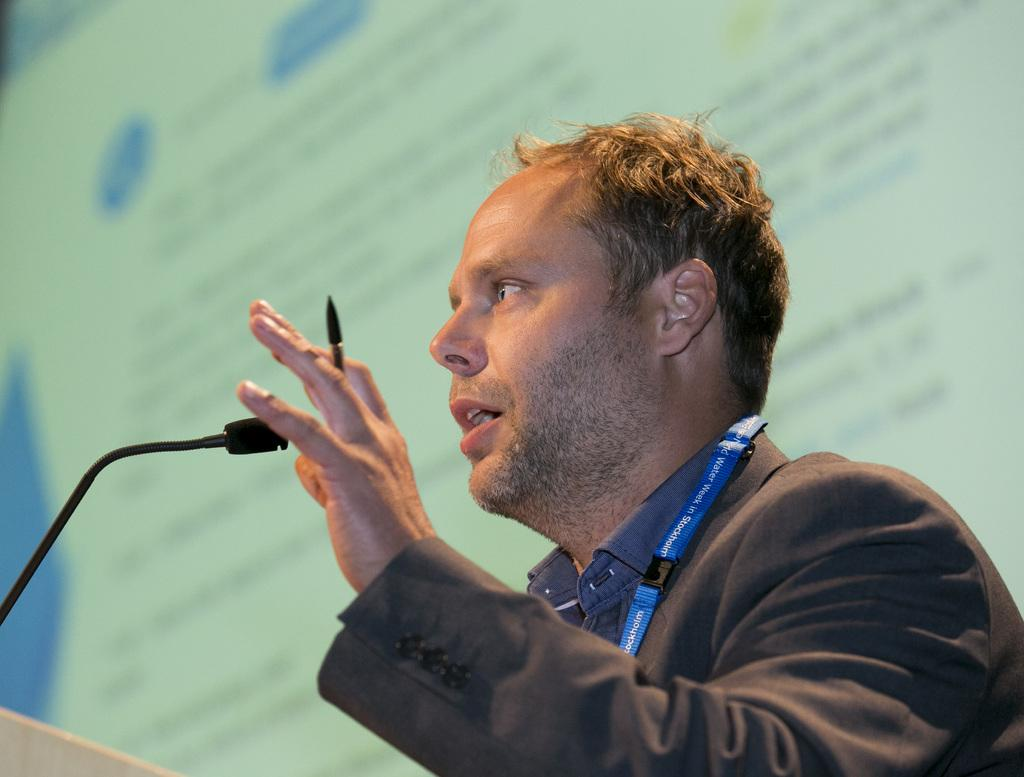Who is present in the image? There is a man in the image. What is the man wearing that provides identification? The man is wearing an ID card. What is the man holding in his hand? The man is holding a pen. What can be seen on the left side of the image? There is a microphone on the left side of the image. What type of background is visible in the image? There appears to be a screen wall in the background of the image. How does the man use the spoon in the image? There is no spoon present in the image. What type of loss is the man experiencing in the image? There is no indication of loss in the image; the man is holding a pen and wearing an ID card. 